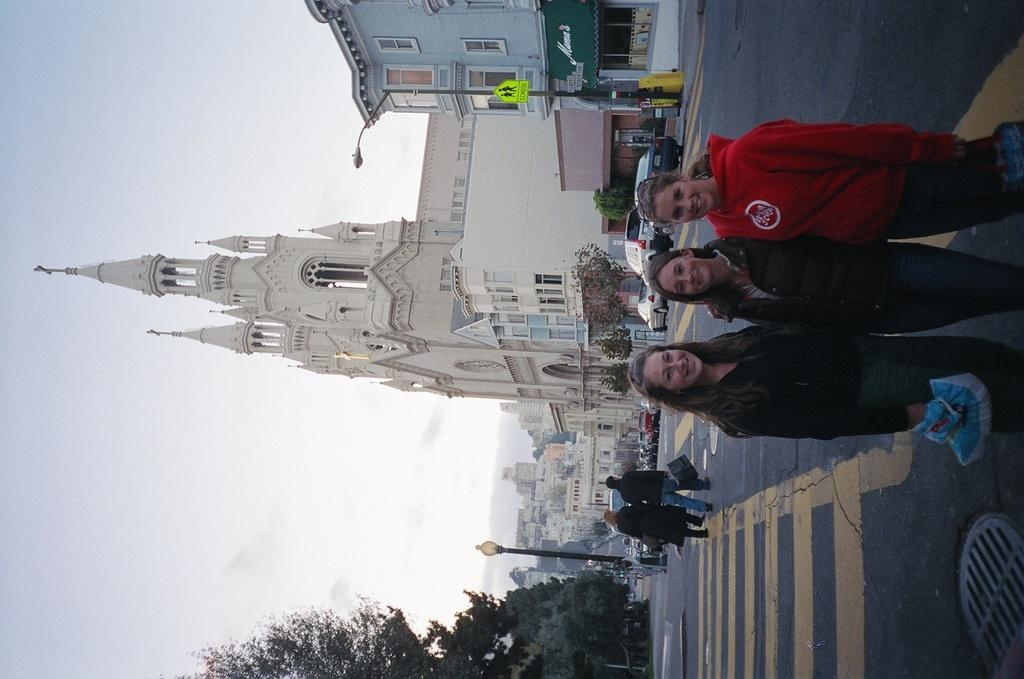Who or what can be seen on the right side of the image? There are people on the right side of the image. What type of structures are visible at the top of the image? There are buildings visible at the top of the image. How many twigs are being held by the people on the right side of the image? There are no twigs visible in the image; the people are not holding any twigs. Are the people on the right side of the image sisters? The provided facts do not mention any information about the relationship between the people, so we cannot determine if they are sisters or not. 